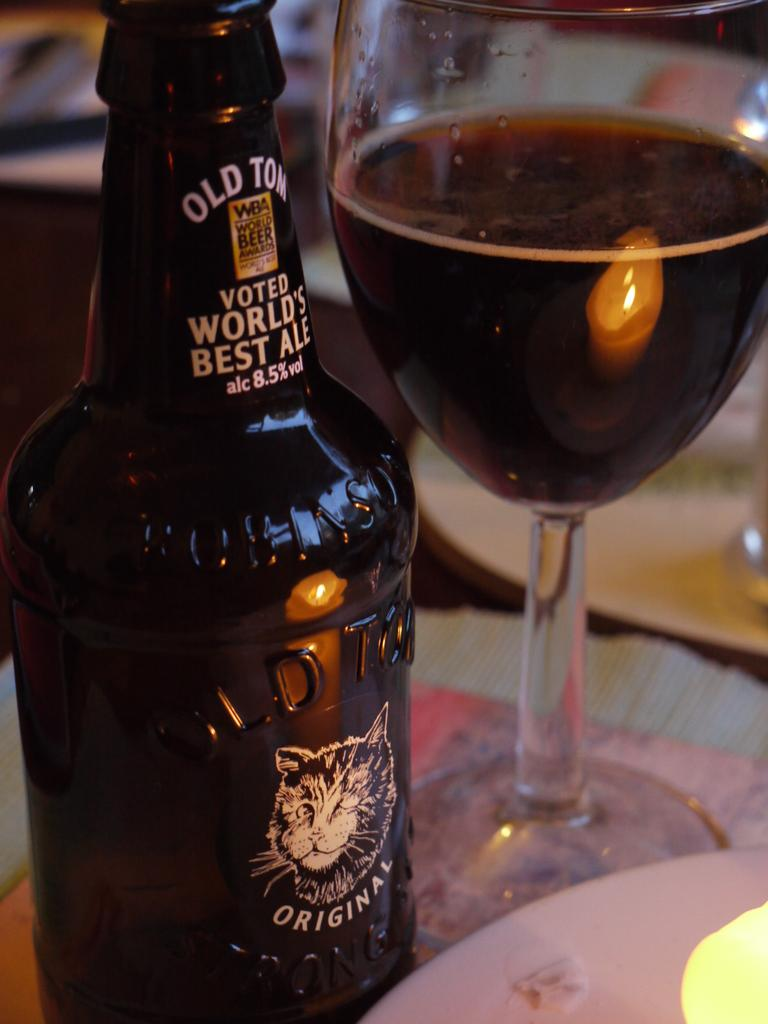<image>
Provide a brief description of the given image. A bottle of Original Ale with a cat logon on the bottle sits to the left of a wine glass that is half way filled with ale. 